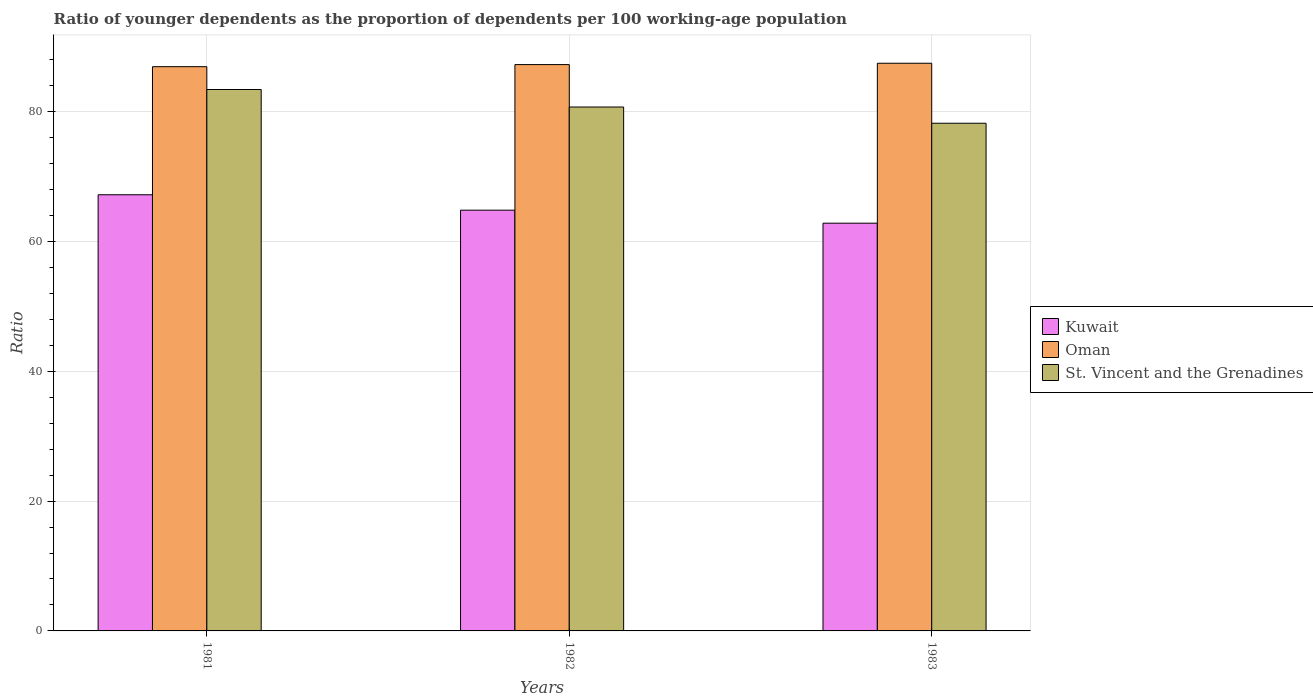How many different coloured bars are there?
Keep it short and to the point. 3. How many groups of bars are there?
Your response must be concise. 3. How many bars are there on the 2nd tick from the left?
Ensure brevity in your answer.  3. How many bars are there on the 2nd tick from the right?
Keep it short and to the point. 3. In how many cases, is the number of bars for a given year not equal to the number of legend labels?
Make the answer very short. 0. What is the age dependency ratio(young) in Kuwait in 1981?
Provide a succinct answer. 67.2. Across all years, what is the maximum age dependency ratio(young) in Oman?
Your answer should be compact. 87.47. Across all years, what is the minimum age dependency ratio(young) in Kuwait?
Ensure brevity in your answer.  62.82. In which year was the age dependency ratio(young) in St. Vincent and the Grenadines maximum?
Your response must be concise. 1981. In which year was the age dependency ratio(young) in Kuwait minimum?
Offer a terse response. 1983. What is the total age dependency ratio(young) in Oman in the graph?
Offer a terse response. 261.66. What is the difference between the age dependency ratio(young) in Oman in 1981 and that in 1982?
Provide a succinct answer. -0.32. What is the difference between the age dependency ratio(young) in St. Vincent and the Grenadines in 1982 and the age dependency ratio(young) in Oman in 1983?
Your response must be concise. -6.74. What is the average age dependency ratio(young) in Oman per year?
Offer a terse response. 87.22. In the year 1983, what is the difference between the age dependency ratio(young) in St. Vincent and the Grenadines and age dependency ratio(young) in Kuwait?
Your answer should be very brief. 15.4. In how many years, is the age dependency ratio(young) in Kuwait greater than 4?
Give a very brief answer. 3. What is the ratio of the age dependency ratio(young) in Kuwait in 1981 to that in 1982?
Your answer should be compact. 1.04. Is the age dependency ratio(young) in St. Vincent and the Grenadines in 1981 less than that in 1983?
Your response must be concise. No. What is the difference between the highest and the second highest age dependency ratio(young) in St. Vincent and the Grenadines?
Your answer should be very brief. 2.7. What is the difference between the highest and the lowest age dependency ratio(young) in Kuwait?
Ensure brevity in your answer.  4.38. In how many years, is the age dependency ratio(young) in Kuwait greater than the average age dependency ratio(young) in Kuwait taken over all years?
Offer a terse response. 1. Is the sum of the age dependency ratio(young) in Kuwait in 1981 and 1982 greater than the maximum age dependency ratio(young) in Oman across all years?
Offer a terse response. Yes. What does the 1st bar from the left in 1981 represents?
Your answer should be very brief. Kuwait. What does the 1st bar from the right in 1982 represents?
Provide a short and direct response. St. Vincent and the Grenadines. How many bars are there?
Offer a very short reply. 9. How many years are there in the graph?
Give a very brief answer. 3. What is the difference between two consecutive major ticks on the Y-axis?
Your response must be concise. 20. Are the values on the major ticks of Y-axis written in scientific E-notation?
Ensure brevity in your answer.  No. Does the graph contain any zero values?
Make the answer very short. No. Does the graph contain grids?
Provide a succinct answer. Yes. How are the legend labels stacked?
Provide a succinct answer. Vertical. What is the title of the graph?
Your answer should be very brief. Ratio of younger dependents as the proportion of dependents per 100 working-age population. What is the label or title of the Y-axis?
Your response must be concise. Ratio. What is the Ratio in Kuwait in 1981?
Keep it short and to the point. 67.2. What is the Ratio in Oman in 1981?
Provide a short and direct response. 86.94. What is the Ratio of St. Vincent and the Grenadines in 1981?
Your answer should be compact. 83.42. What is the Ratio of Kuwait in 1982?
Keep it short and to the point. 64.83. What is the Ratio in Oman in 1982?
Keep it short and to the point. 87.26. What is the Ratio in St. Vincent and the Grenadines in 1982?
Provide a short and direct response. 80.72. What is the Ratio in Kuwait in 1983?
Your response must be concise. 62.82. What is the Ratio in Oman in 1983?
Give a very brief answer. 87.47. What is the Ratio in St. Vincent and the Grenadines in 1983?
Ensure brevity in your answer.  78.22. Across all years, what is the maximum Ratio of Kuwait?
Ensure brevity in your answer.  67.2. Across all years, what is the maximum Ratio of Oman?
Provide a short and direct response. 87.47. Across all years, what is the maximum Ratio of St. Vincent and the Grenadines?
Your answer should be compact. 83.42. Across all years, what is the minimum Ratio of Kuwait?
Make the answer very short. 62.82. Across all years, what is the minimum Ratio in Oman?
Your response must be concise. 86.94. Across all years, what is the minimum Ratio of St. Vincent and the Grenadines?
Give a very brief answer. 78.22. What is the total Ratio of Kuwait in the graph?
Ensure brevity in your answer.  194.86. What is the total Ratio in Oman in the graph?
Make the answer very short. 261.66. What is the total Ratio in St. Vincent and the Grenadines in the graph?
Your answer should be very brief. 242.37. What is the difference between the Ratio of Kuwait in 1981 and that in 1982?
Make the answer very short. 2.37. What is the difference between the Ratio of Oman in 1981 and that in 1982?
Provide a short and direct response. -0.32. What is the difference between the Ratio in St. Vincent and the Grenadines in 1981 and that in 1982?
Offer a very short reply. 2.7. What is the difference between the Ratio of Kuwait in 1981 and that in 1983?
Keep it short and to the point. 4.38. What is the difference between the Ratio of Oman in 1981 and that in 1983?
Ensure brevity in your answer.  -0.53. What is the difference between the Ratio of St. Vincent and the Grenadines in 1981 and that in 1983?
Offer a very short reply. 5.2. What is the difference between the Ratio of Kuwait in 1982 and that in 1983?
Keep it short and to the point. 2. What is the difference between the Ratio of Oman in 1982 and that in 1983?
Your response must be concise. -0.21. What is the difference between the Ratio in St. Vincent and the Grenadines in 1982 and that in 1983?
Provide a succinct answer. 2.5. What is the difference between the Ratio in Kuwait in 1981 and the Ratio in Oman in 1982?
Offer a terse response. -20.06. What is the difference between the Ratio of Kuwait in 1981 and the Ratio of St. Vincent and the Grenadines in 1982?
Provide a short and direct response. -13.52. What is the difference between the Ratio of Oman in 1981 and the Ratio of St. Vincent and the Grenadines in 1982?
Your answer should be very brief. 6.21. What is the difference between the Ratio of Kuwait in 1981 and the Ratio of Oman in 1983?
Make the answer very short. -20.26. What is the difference between the Ratio in Kuwait in 1981 and the Ratio in St. Vincent and the Grenadines in 1983?
Give a very brief answer. -11.02. What is the difference between the Ratio in Oman in 1981 and the Ratio in St. Vincent and the Grenadines in 1983?
Offer a terse response. 8.71. What is the difference between the Ratio of Kuwait in 1982 and the Ratio of Oman in 1983?
Your answer should be compact. -22.64. What is the difference between the Ratio of Kuwait in 1982 and the Ratio of St. Vincent and the Grenadines in 1983?
Your response must be concise. -13.39. What is the difference between the Ratio in Oman in 1982 and the Ratio in St. Vincent and the Grenadines in 1983?
Provide a short and direct response. 9.04. What is the average Ratio of Kuwait per year?
Offer a very short reply. 64.95. What is the average Ratio of Oman per year?
Your answer should be very brief. 87.22. What is the average Ratio in St. Vincent and the Grenadines per year?
Give a very brief answer. 80.79. In the year 1981, what is the difference between the Ratio of Kuwait and Ratio of Oman?
Keep it short and to the point. -19.73. In the year 1981, what is the difference between the Ratio in Kuwait and Ratio in St. Vincent and the Grenadines?
Keep it short and to the point. -16.22. In the year 1981, what is the difference between the Ratio of Oman and Ratio of St. Vincent and the Grenadines?
Offer a terse response. 3.52. In the year 1982, what is the difference between the Ratio of Kuwait and Ratio of Oman?
Offer a very short reply. -22.43. In the year 1982, what is the difference between the Ratio of Kuwait and Ratio of St. Vincent and the Grenadines?
Provide a short and direct response. -15.9. In the year 1982, what is the difference between the Ratio of Oman and Ratio of St. Vincent and the Grenadines?
Ensure brevity in your answer.  6.54. In the year 1983, what is the difference between the Ratio of Kuwait and Ratio of Oman?
Offer a terse response. -24.64. In the year 1983, what is the difference between the Ratio in Kuwait and Ratio in St. Vincent and the Grenadines?
Your answer should be very brief. -15.4. In the year 1983, what is the difference between the Ratio in Oman and Ratio in St. Vincent and the Grenadines?
Offer a terse response. 9.24. What is the ratio of the Ratio in Kuwait in 1981 to that in 1982?
Offer a very short reply. 1.04. What is the ratio of the Ratio in St. Vincent and the Grenadines in 1981 to that in 1982?
Provide a short and direct response. 1.03. What is the ratio of the Ratio of Kuwait in 1981 to that in 1983?
Provide a short and direct response. 1.07. What is the ratio of the Ratio of Oman in 1981 to that in 1983?
Offer a very short reply. 0.99. What is the ratio of the Ratio of St. Vincent and the Grenadines in 1981 to that in 1983?
Ensure brevity in your answer.  1.07. What is the ratio of the Ratio of Kuwait in 1982 to that in 1983?
Your answer should be compact. 1.03. What is the ratio of the Ratio in St. Vincent and the Grenadines in 1982 to that in 1983?
Provide a succinct answer. 1.03. What is the difference between the highest and the second highest Ratio of Kuwait?
Your answer should be very brief. 2.37. What is the difference between the highest and the second highest Ratio of Oman?
Your answer should be compact. 0.21. What is the difference between the highest and the second highest Ratio in St. Vincent and the Grenadines?
Offer a very short reply. 2.7. What is the difference between the highest and the lowest Ratio in Kuwait?
Offer a very short reply. 4.38. What is the difference between the highest and the lowest Ratio of Oman?
Give a very brief answer. 0.53. What is the difference between the highest and the lowest Ratio of St. Vincent and the Grenadines?
Offer a terse response. 5.2. 